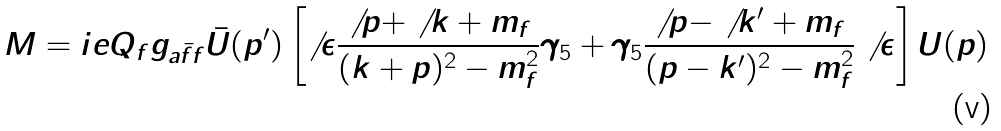<formula> <loc_0><loc_0><loc_500><loc_500>M = i e Q _ { f } g _ { a \bar { f } f } \bar { U } ( p ^ { \prime } ) \left [ \not \, \epsilon \frac { \not \, p + \not \, k + m _ { f } } { ( k + p ) ^ { 2 } - m _ { f } ^ { 2 } } \gamma _ { 5 } + \gamma _ { 5 } \frac { \not \, p - \not \, k ^ { \prime } + m _ { f } } { ( p - k ^ { \prime } ) ^ { 2 } - m _ { f } ^ { 2 } } \not \, \epsilon \right ] U ( p )</formula> 